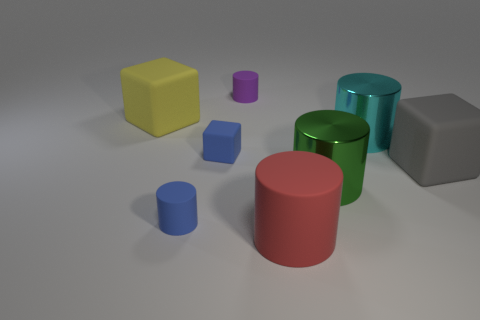How many objects are either small blue things that are in front of the small cube or things right of the purple cylinder?
Provide a succinct answer. 5. What number of other things are there of the same shape as the red thing?
Your answer should be very brief. 4. Is the color of the big thing that is to the left of the red matte cylinder the same as the tiny cube?
Keep it short and to the point. No. What number of other things are the same size as the cyan metal cylinder?
Your answer should be very brief. 4. Is the material of the green thing the same as the big yellow cube?
Your answer should be compact. No. The cylinder that is left of the matte object that is behind the large yellow matte block is what color?
Keep it short and to the point. Blue. What is the size of the cyan object that is the same shape as the green thing?
Provide a short and direct response. Large. Is the color of the large matte cylinder the same as the tiny rubber block?
Keep it short and to the point. No. There is a tiny rubber cylinder that is behind the tiny blue matte object that is behind the big gray rubber object; how many big matte cylinders are in front of it?
Provide a succinct answer. 1. Are there more tiny blue matte blocks than tiny yellow metal cylinders?
Your answer should be very brief. Yes. 